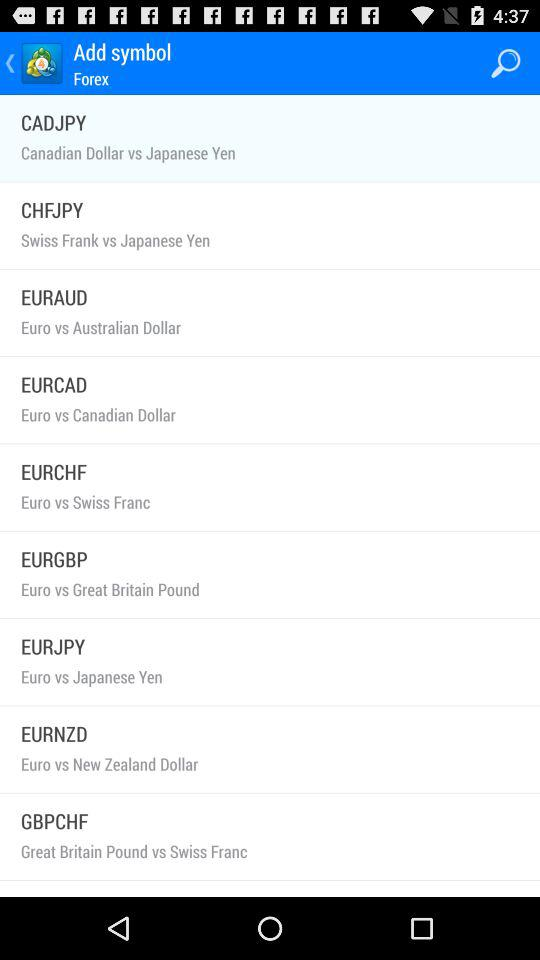What is the mentioned symbol for the "Euro vs Canadian Dollar"? The mentioned symbol is "EURCAD". 